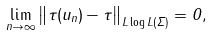Convert formula to latex. <formula><loc_0><loc_0><loc_500><loc_500>\lim _ { n \rightarrow \infty } \left \| \tau ( u _ { n } ) - \tau \right \| _ { L \log L ( \Sigma ) } = 0 ,</formula> 